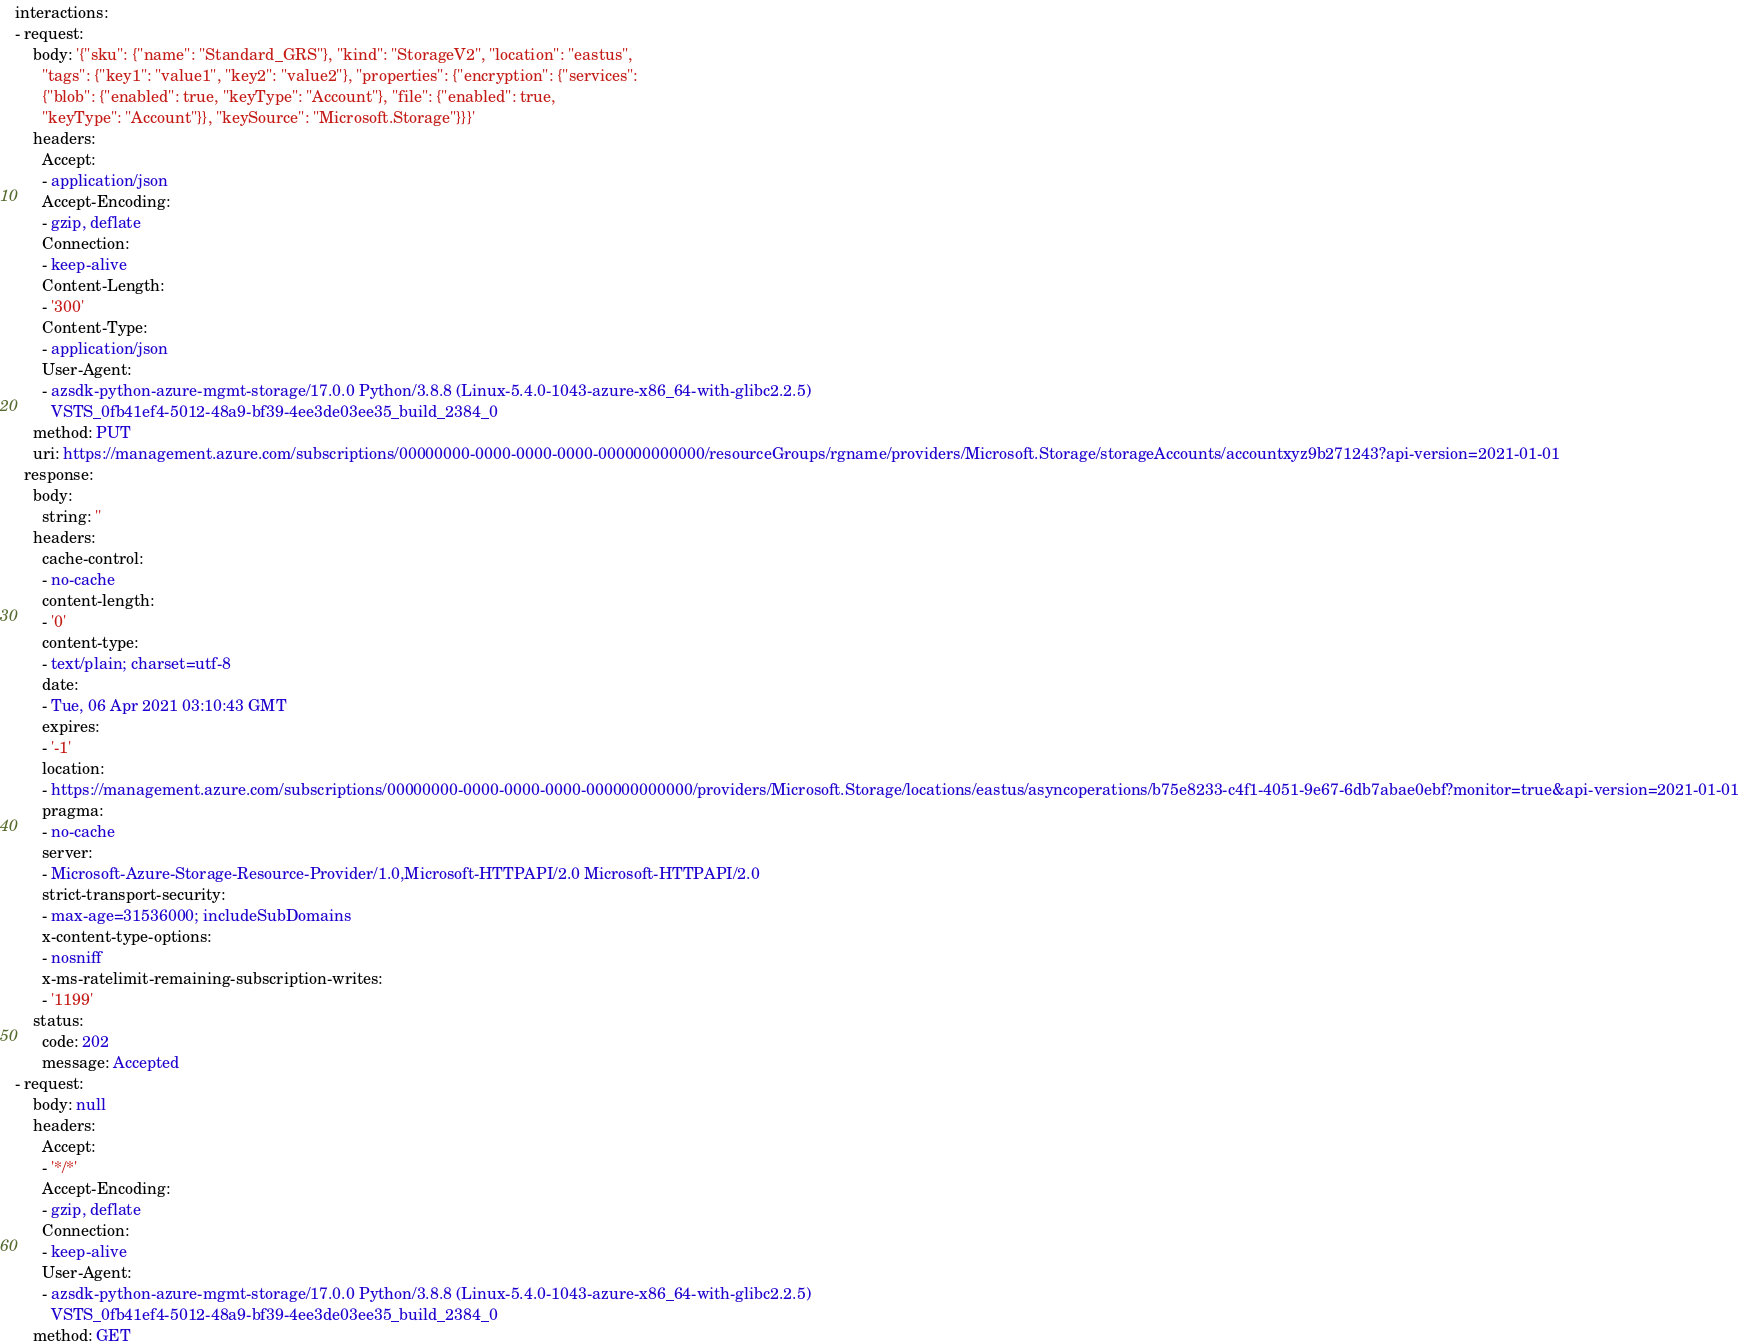Convert code to text. <code><loc_0><loc_0><loc_500><loc_500><_YAML_>interactions:
- request:
    body: '{"sku": {"name": "Standard_GRS"}, "kind": "StorageV2", "location": "eastus",
      "tags": {"key1": "value1", "key2": "value2"}, "properties": {"encryption": {"services":
      {"blob": {"enabled": true, "keyType": "Account"}, "file": {"enabled": true,
      "keyType": "Account"}}, "keySource": "Microsoft.Storage"}}}'
    headers:
      Accept:
      - application/json
      Accept-Encoding:
      - gzip, deflate
      Connection:
      - keep-alive
      Content-Length:
      - '300'
      Content-Type:
      - application/json
      User-Agent:
      - azsdk-python-azure-mgmt-storage/17.0.0 Python/3.8.8 (Linux-5.4.0-1043-azure-x86_64-with-glibc2.2.5)
        VSTS_0fb41ef4-5012-48a9-bf39-4ee3de03ee35_build_2384_0
    method: PUT
    uri: https://management.azure.com/subscriptions/00000000-0000-0000-0000-000000000000/resourceGroups/rgname/providers/Microsoft.Storage/storageAccounts/accountxyz9b271243?api-version=2021-01-01
  response:
    body:
      string: ''
    headers:
      cache-control:
      - no-cache
      content-length:
      - '0'
      content-type:
      - text/plain; charset=utf-8
      date:
      - Tue, 06 Apr 2021 03:10:43 GMT
      expires:
      - '-1'
      location:
      - https://management.azure.com/subscriptions/00000000-0000-0000-0000-000000000000/providers/Microsoft.Storage/locations/eastus/asyncoperations/b75e8233-c4f1-4051-9e67-6db7abae0ebf?monitor=true&api-version=2021-01-01
      pragma:
      - no-cache
      server:
      - Microsoft-Azure-Storage-Resource-Provider/1.0,Microsoft-HTTPAPI/2.0 Microsoft-HTTPAPI/2.0
      strict-transport-security:
      - max-age=31536000; includeSubDomains
      x-content-type-options:
      - nosniff
      x-ms-ratelimit-remaining-subscription-writes:
      - '1199'
    status:
      code: 202
      message: Accepted
- request:
    body: null
    headers:
      Accept:
      - '*/*'
      Accept-Encoding:
      - gzip, deflate
      Connection:
      - keep-alive
      User-Agent:
      - azsdk-python-azure-mgmt-storage/17.0.0 Python/3.8.8 (Linux-5.4.0-1043-azure-x86_64-with-glibc2.2.5)
        VSTS_0fb41ef4-5012-48a9-bf39-4ee3de03ee35_build_2384_0
    method: GET</code> 